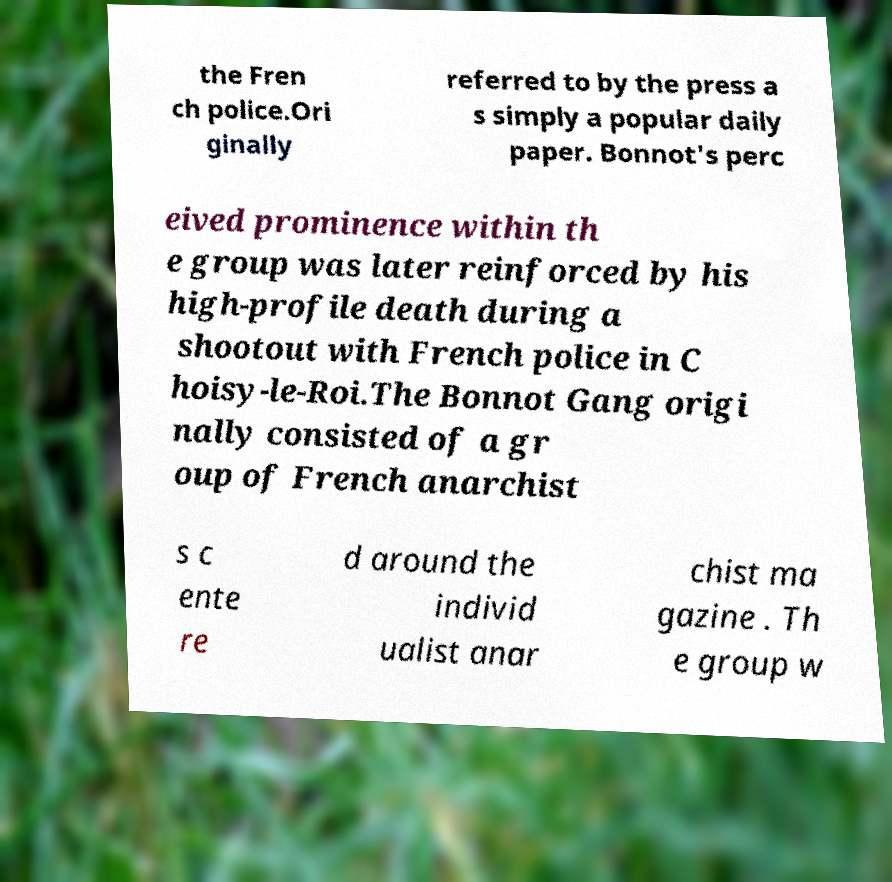Please read and relay the text visible in this image. What does it say? the Fren ch police.Ori ginally referred to by the press a s simply a popular daily paper. Bonnot's perc eived prominence within th e group was later reinforced by his high-profile death during a shootout with French police in C hoisy-le-Roi.The Bonnot Gang origi nally consisted of a gr oup of French anarchist s c ente re d around the individ ualist anar chist ma gazine . Th e group w 